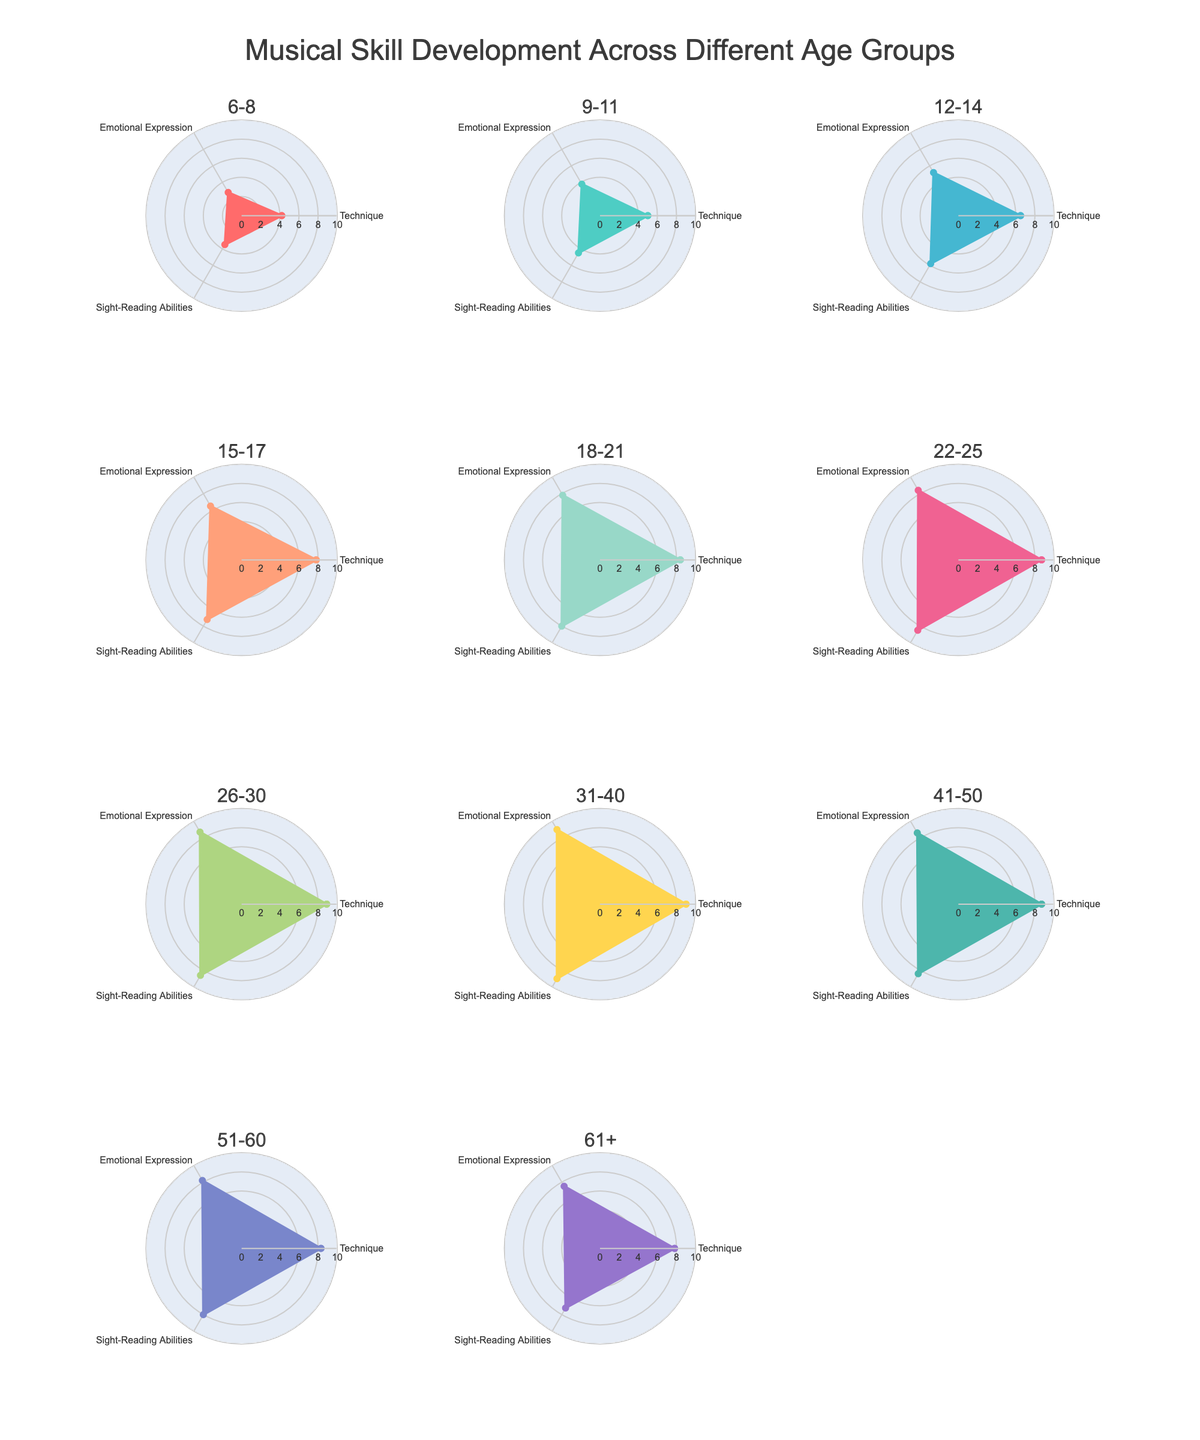What's the title of the figure? The title is located at the top of the figure, often displayed in larger font size.
Answer: Musical Skill Development Across Different Age Groups Which age group has the highest skill in Technique? By examining the radar charts, the Technique skill can be compared. The age group with the greatest extent on the Technique axis is observed.
Answer: 31-40 Which skill category shows the most consistent development across all age groups? If we compare the three skill categories (Technique, Emotional Expression, Sight-Reading Abilities) and observe their growth patterns across all the age groups, the one with relatively consistent development will have a smooth and gradual increase or remain stable.
Answer: Sight-Reading Abilities What is the difference in the Emotional Expression score between ages 6-8 and 18-21? The Emotional Expression scores for ages 6-8 and 18-21 are 2.8 and 7.8 respectively. Subtract the smaller value from the larger one.
Answer: 5.0 Which age group has the lowest score in Emotional Expression? By examining the individual radar plots for each age group and comparing the values on the Emotional Expression axis, we identify the minimum value.
Answer: 6-8 How does the Sight-Reading Abilities score of the 51-60 age group compare to that of the 22-25 age group? Look at the radar plots for both 51-60 and 22-25. The values are noted as 8.0 for 51-60 and 8.5 for 22-25. Comparing both, 8.0 is less than 8.5.
Answer: Less than Calculate the average Technique skill score for the age groups 12-14, 18-21, and 31-40. The Technique scores are 6.5, 8.4, and 9.0 for the respective age groups. Sum these values and divide by the number of groups. (6.5 + 8.4 + 9.0) / 3 = 7.97
Answer: 7.97 Which age group shows the largest overall spread from the lowest to the highest skill in their radar chart? Here, we assess the maximum and minimum values in each group's radar chart. The group with the largest difference between their highest and lowest skill is identified.
Answer: 6-8 